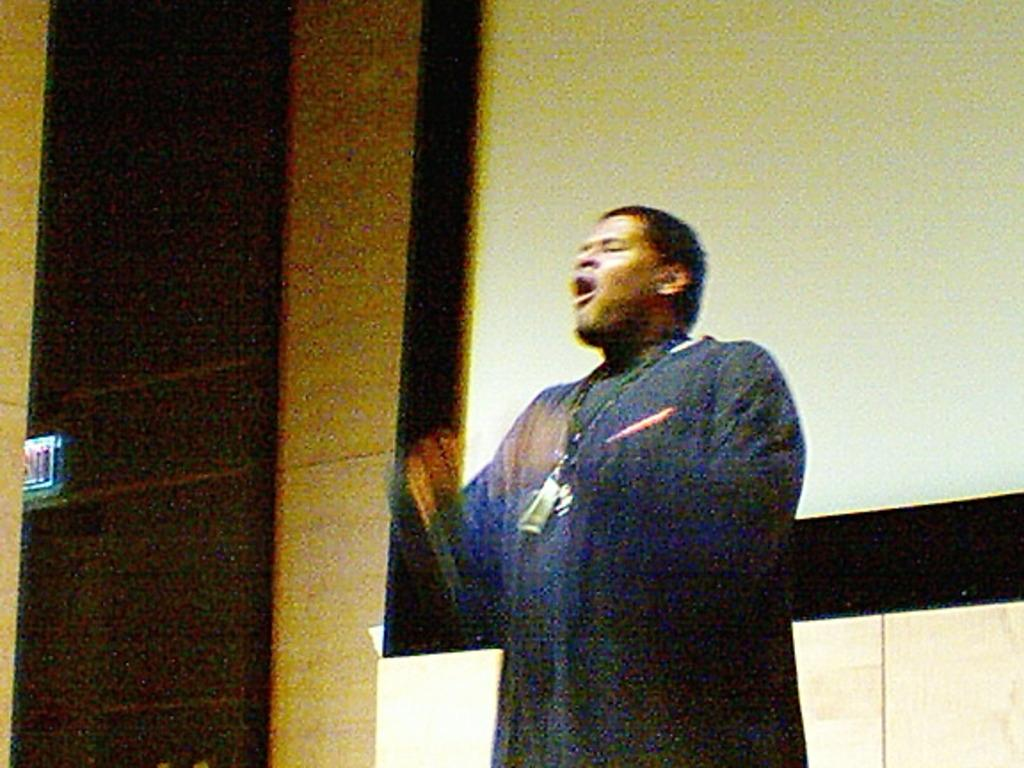What is the main subject of the image? There is a person in the image. What object is present in the image alongside the person? There is a projector screen in the image. What type of fowl can be seen on the projector screen? There is no mention of a fowl or any other object on the projector screen in the image. 